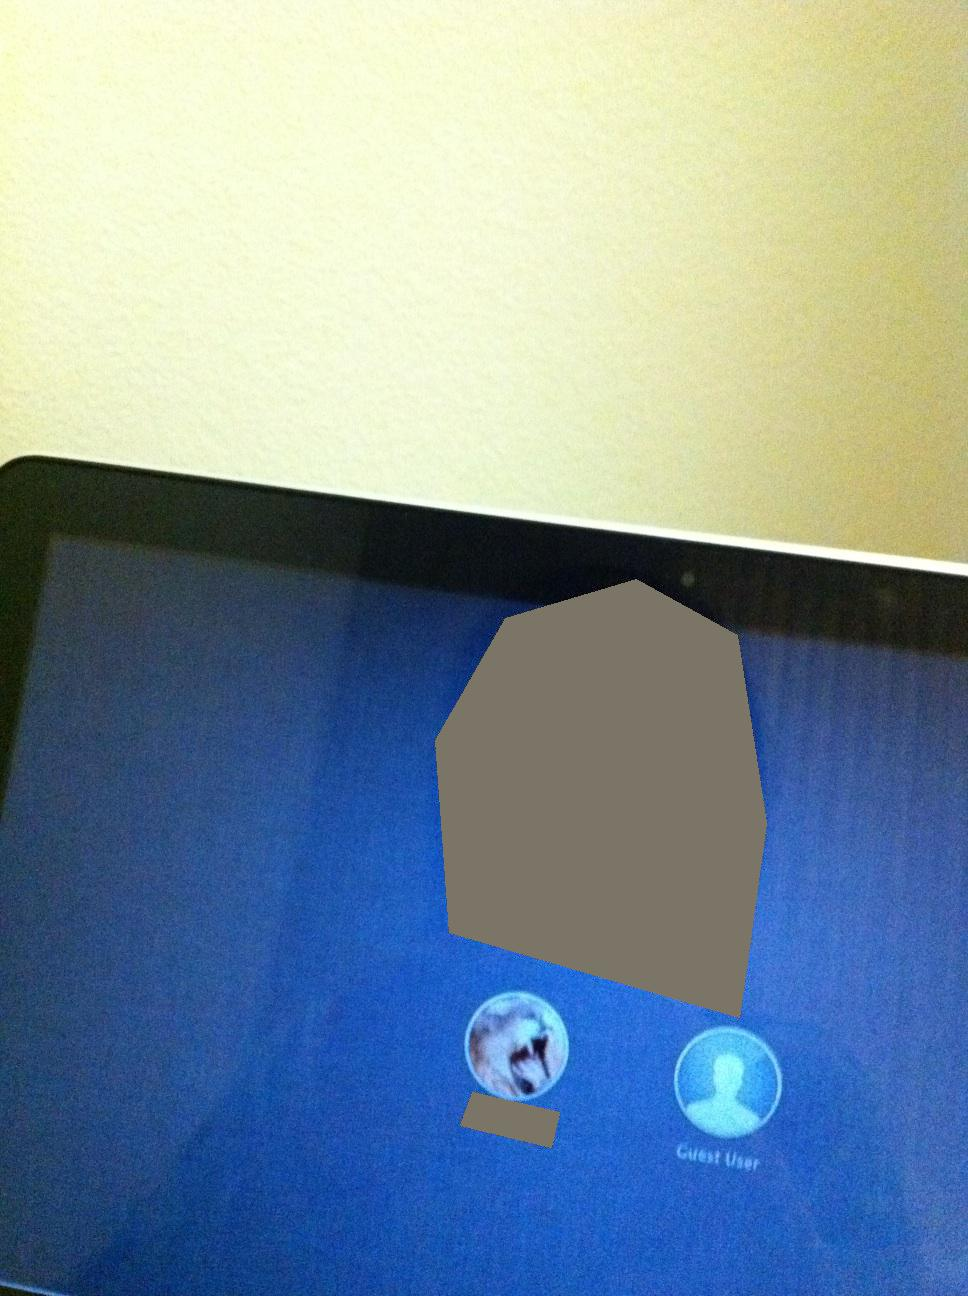How would these characters interact in a setting that brings their unique abilities into focus? Lyra and Aelan would find themselves drawn together by destiny. Lyra could summon storms to confront threats looming over their world, while Aelan, with his knowledge from countless records, helps decode ancient texts crucial for their quests. They balance each other—Lyra brings power and action, while Aelan brings wisdom and strategy. Their interactions might range from dramatic partnerships in battle to deep, philosophical conversations about the magical world, often with Aelan recording their adventures to share with future generations. 